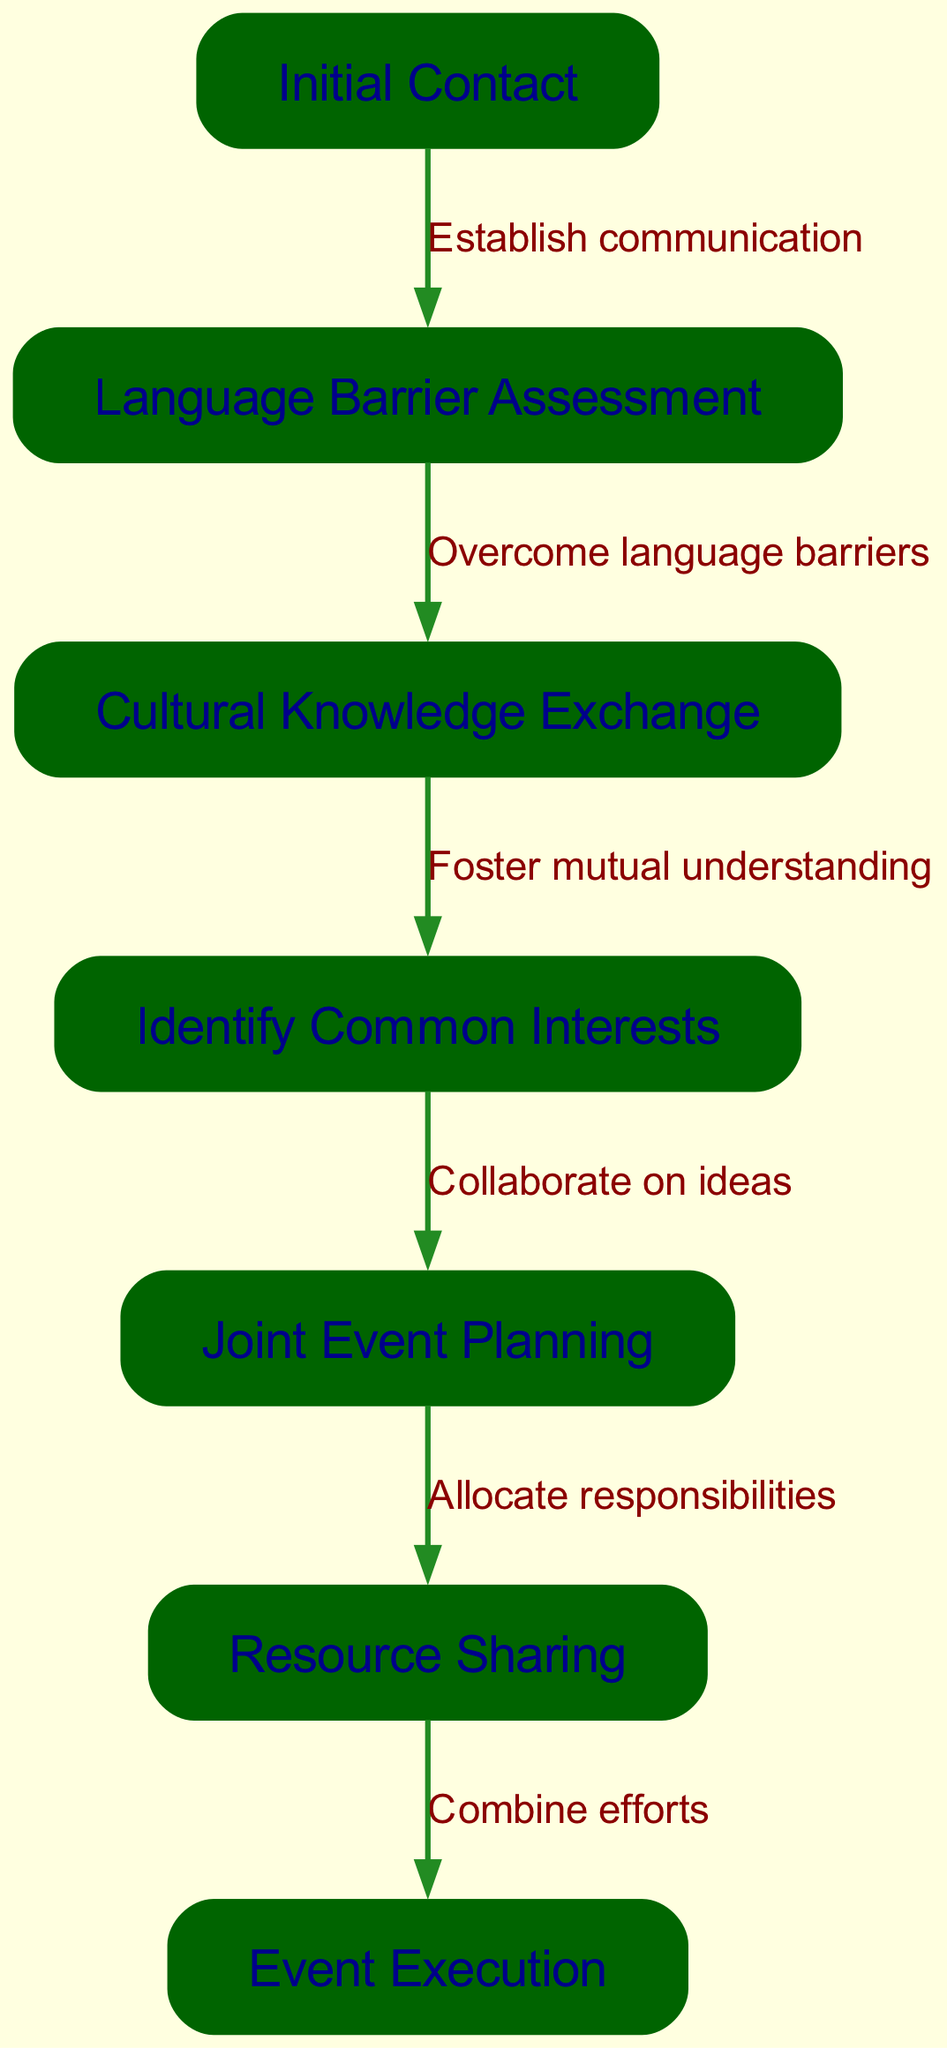What is the starting point of the communication process? The starting point is indicated by the label of the first node in the diagram, which is "Initial Contact." This node signifies the beginning of the cross-cultural communication process.
Answer: Initial Contact How many nodes are present in the diagram? The number of nodes can be counted by reviewing the first section of the data, where there are a total of 7 nodes listed.
Answer: 7 What is the relationship between "Language Barrier Assessment" and "Cultural Knowledge Exchange"? The relationship is described by the edge between node 2 (Language Barrier Assessment) and node 3 (Cultural Knowledge Exchange), with the label indicating that this edge focuses on overcoming language barriers.
Answer: Overcome language barriers Which node follows "Identify Common Interests"? The flow from the diagram can be traced from node 4 (Identify Common Interests) to node 5 (Joint Event Planning), indicating that Joint Event Planning follows after identifying common interests.
Answer: Joint Event Planning What does the edge from "Resource Sharing" point to? The specific edge in question starts at node 6 (Resource Sharing) and points to node 7 (Event Execution), which indicates the culmination of combined efforts after sharing resources.
Answer: Event Execution What is the significance of the edge connecting "Cultural Knowledge Exchange" and "Identify Common Interests"? This edge represents the idea that through fostering mutual understanding, communities can collaborate to identify shared interests, which is essential for effective joint planning.
Answer: Foster mutual understanding How many edges are represented in the diagram? By examining the edges listed in the data, there are 6 edges that connect the various nodes in the communication process.
Answer: 6 What is the final outcome of the communication process? The final outcome is represented by the last node in the flow, which is "Event Execution," indicating the successful culmination of the planning process.
Answer: Event Execution 